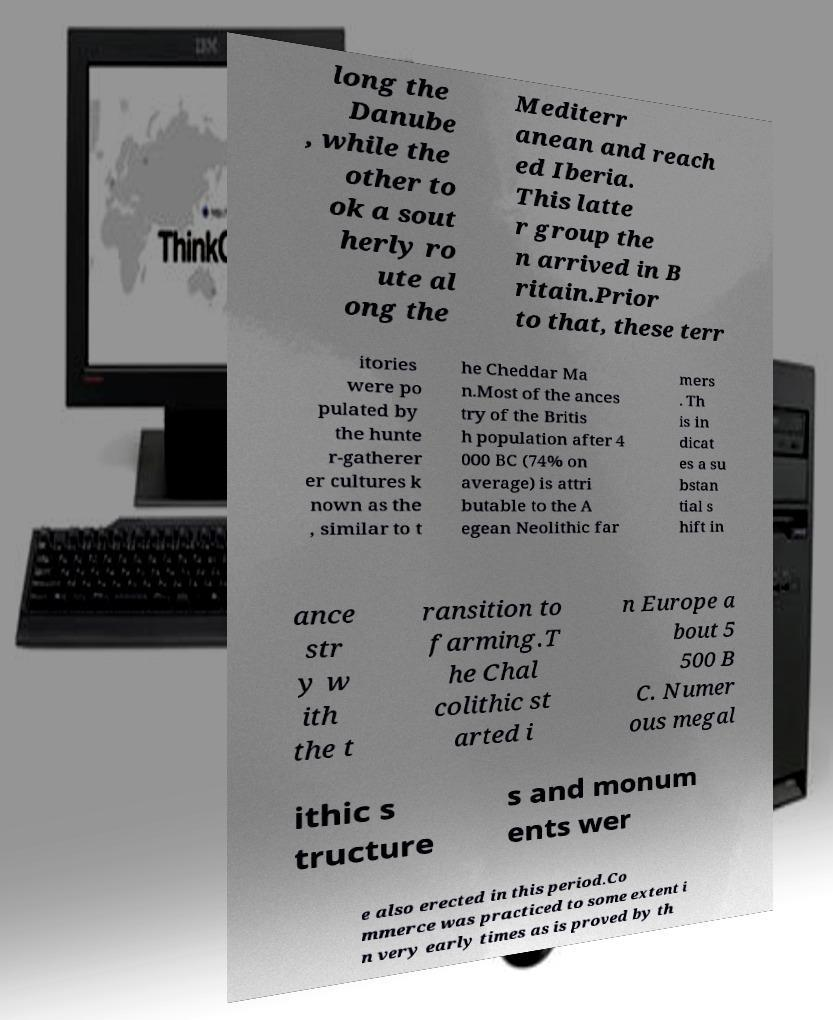Can you accurately transcribe the text from the provided image for me? long the Danube , while the other to ok a sout herly ro ute al ong the Mediterr anean and reach ed Iberia. This latte r group the n arrived in B ritain.Prior to that, these terr itories were po pulated by the hunte r-gatherer er cultures k nown as the , similar to t he Cheddar Ma n.Most of the ances try of the Britis h population after 4 000 BC (74% on average) is attri butable to the A egean Neolithic far mers . Th is in dicat es a su bstan tial s hift in ance str y w ith the t ransition to farming.T he Chal colithic st arted i n Europe a bout 5 500 B C. Numer ous megal ithic s tructure s and monum ents wer e also erected in this period.Co mmerce was practiced to some extent i n very early times as is proved by th 